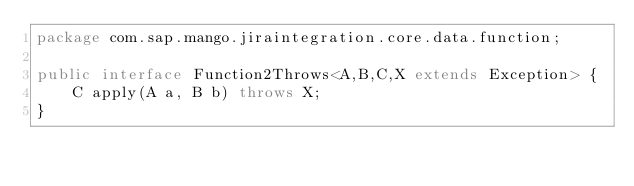Convert code to text. <code><loc_0><loc_0><loc_500><loc_500><_Java_>package com.sap.mango.jiraintegration.core.data.function;

public interface Function2Throws<A,B,C,X extends Exception> {
    C apply(A a, B b) throws X;
}
</code> 